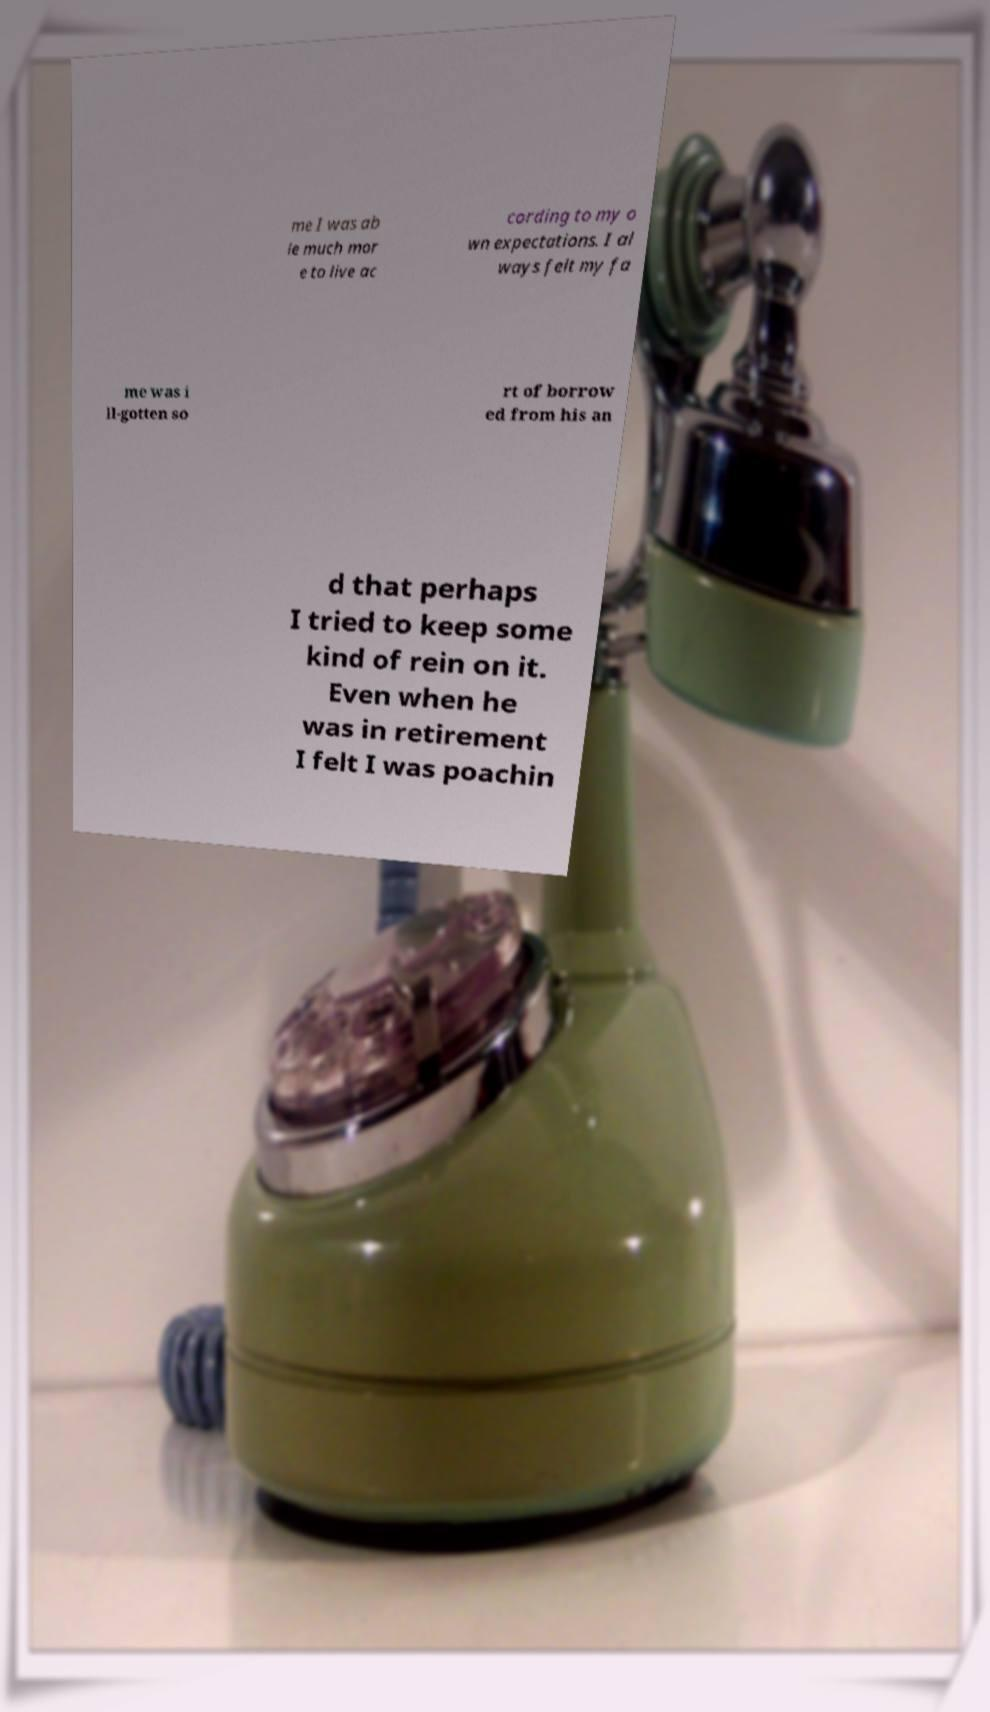Could you extract and type out the text from this image? me I was ab le much mor e to live ac cording to my o wn expectations. I al ways felt my fa me was i ll-gotten so rt of borrow ed from his an d that perhaps I tried to keep some kind of rein on it. Even when he was in retirement I felt I was poachin 